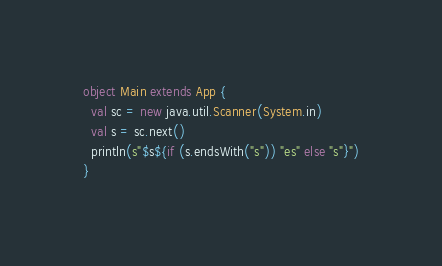<code> <loc_0><loc_0><loc_500><loc_500><_Scala_>object Main extends App {
  val sc = new java.util.Scanner(System.in)
  val s = sc.next()
  println(s"$s${if (s.endsWith("s")) "es" else "s"}")
}
</code> 